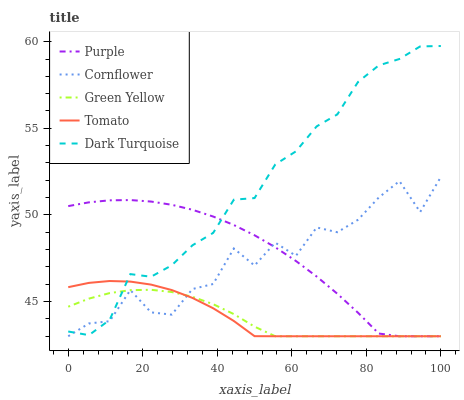Does Green Yellow have the minimum area under the curve?
Answer yes or no. Yes. Does Dark Turquoise have the maximum area under the curve?
Answer yes or no. Yes. Does Cornflower have the minimum area under the curve?
Answer yes or no. No. Does Cornflower have the maximum area under the curve?
Answer yes or no. No. Is Green Yellow the smoothest?
Answer yes or no. Yes. Is Cornflower the roughest?
Answer yes or no. Yes. Is Tomato the smoothest?
Answer yes or no. No. Is Tomato the roughest?
Answer yes or no. No. Does Purple have the lowest value?
Answer yes or no. Yes. Does Dark Turquoise have the lowest value?
Answer yes or no. No. Does Dark Turquoise have the highest value?
Answer yes or no. Yes. Does Cornflower have the highest value?
Answer yes or no. No. Does Cornflower intersect Tomato?
Answer yes or no. Yes. Is Cornflower less than Tomato?
Answer yes or no. No. Is Cornflower greater than Tomato?
Answer yes or no. No. 